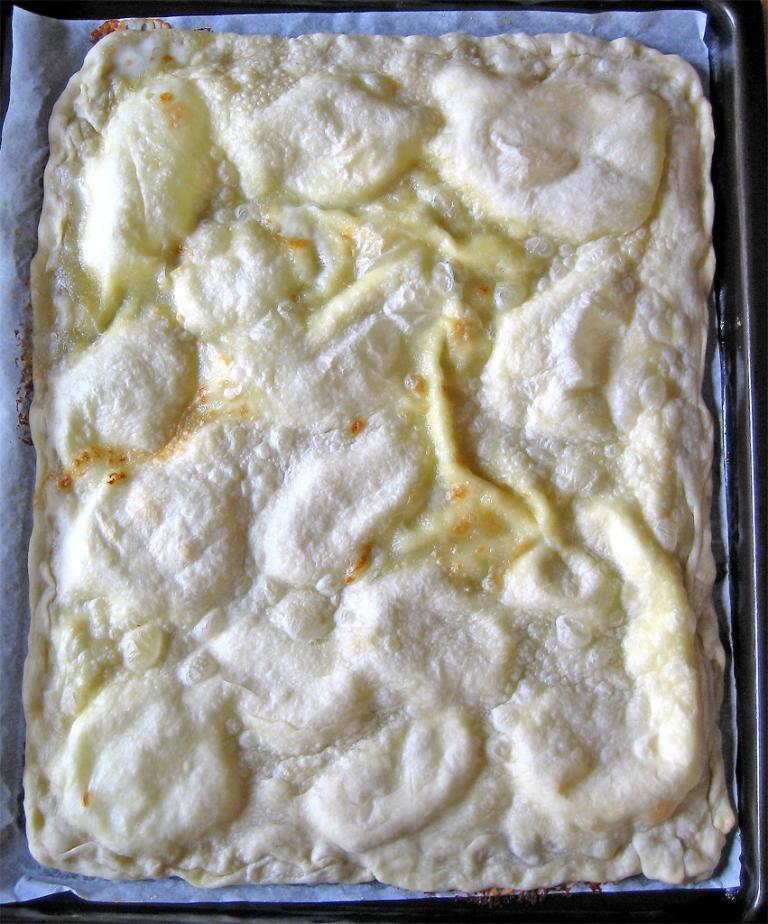Describe this image in one or two sentences. This image consists of food items in a tray. This image is taken may be in a room. 